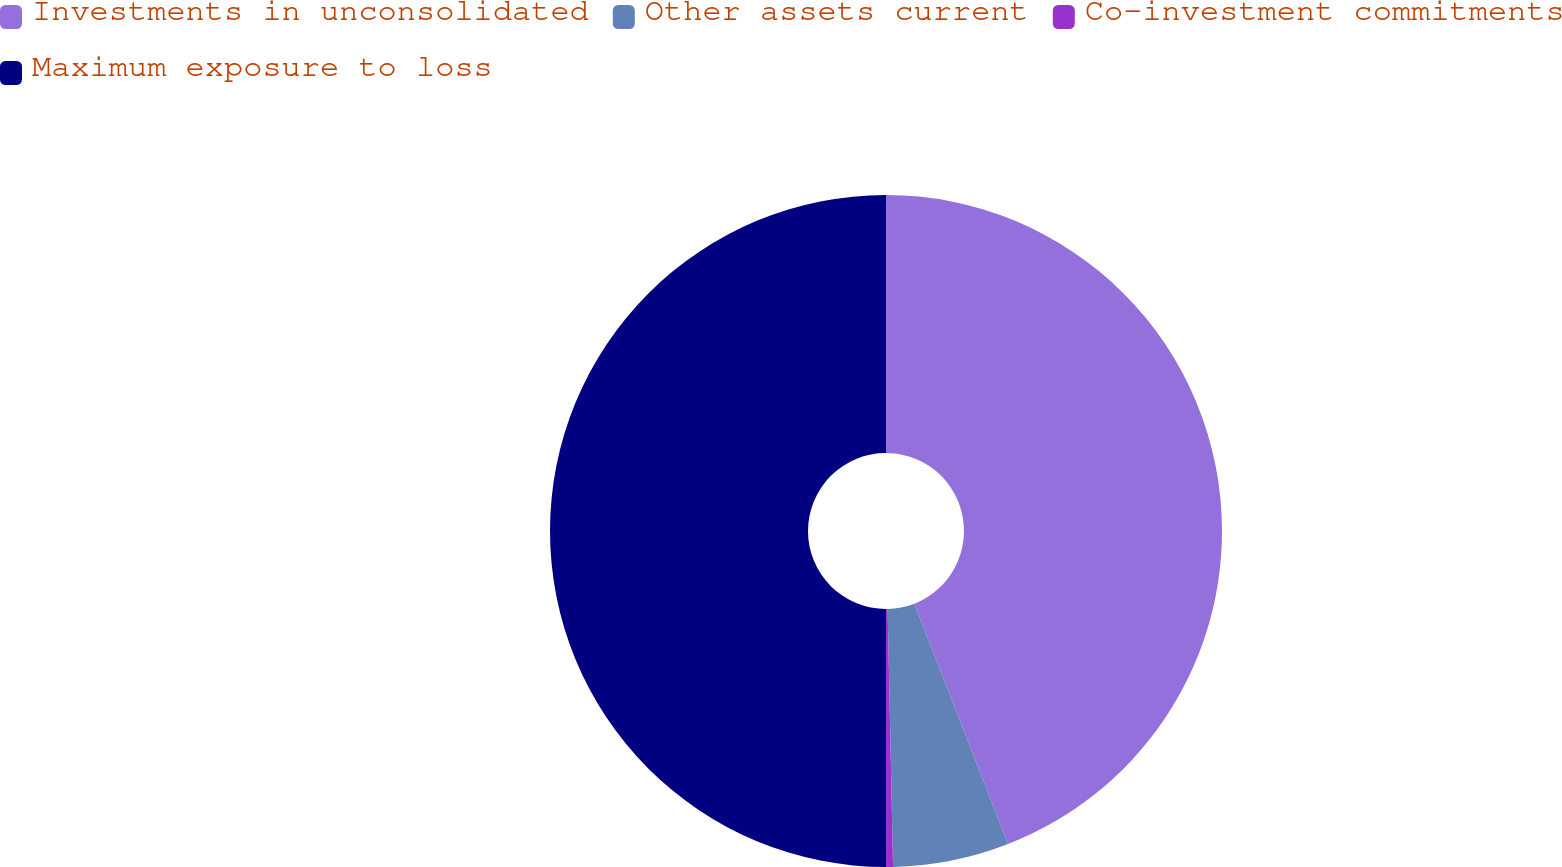Convert chart. <chart><loc_0><loc_0><loc_500><loc_500><pie_chart><fcel>Investments in unconsolidated<fcel>Other assets current<fcel>Co-investment commitments<fcel>Maximum exposure to loss<nl><fcel>44.08%<fcel>5.58%<fcel>0.33%<fcel>50.0%<nl></chart> 